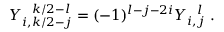<formula> <loc_0><loc_0><loc_500><loc_500>Y _ { i , k / 2 - j } ^ { k / 2 - l } = ( - 1 ) ^ { l - j - 2 i } Y _ { i , j } ^ { l } .</formula> 